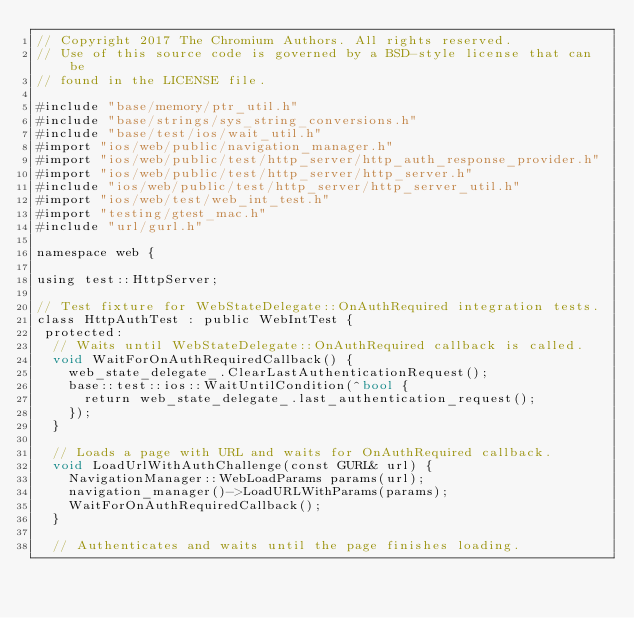Convert code to text. <code><loc_0><loc_0><loc_500><loc_500><_ObjectiveC_>// Copyright 2017 The Chromium Authors. All rights reserved.
// Use of this source code is governed by a BSD-style license that can be
// found in the LICENSE file.

#include "base/memory/ptr_util.h"
#include "base/strings/sys_string_conversions.h"
#include "base/test/ios/wait_util.h"
#import "ios/web/public/navigation_manager.h"
#import "ios/web/public/test/http_server/http_auth_response_provider.h"
#import "ios/web/public/test/http_server/http_server.h"
#include "ios/web/public/test/http_server/http_server_util.h"
#import "ios/web/test/web_int_test.h"
#import "testing/gtest_mac.h"
#include "url/gurl.h"

namespace web {

using test::HttpServer;

// Test fixture for WebStateDelegate::OnAuthRequired integration tests.
class HttpAuthTest : public WebIntTest {
 protected:
  // Waits until WebStateDelegate::OnAuthRequired callback is called.
  void WaitForOnAuthRequiredCallback() {
    web_state_delegate_.ClearLastAuthenticationRequest();
    base::test::ios::WaitUntilCondition(^bool {
      return web_state_delegate_.last_authentication_request();
    });
  }

  // Loads a page with URL and waits for OnAuthRequired callback.
  void LoadUrlWithAuthChallenge(const GURL& url) {
    NavigationManager::WebLoadParams params(url);
    navigation_manager()->LoadURLWithParams(params);
    WaitForOnAuthRequiredCallback();
  }

  // Authenticates and waits until the page finishes loading.</code> 